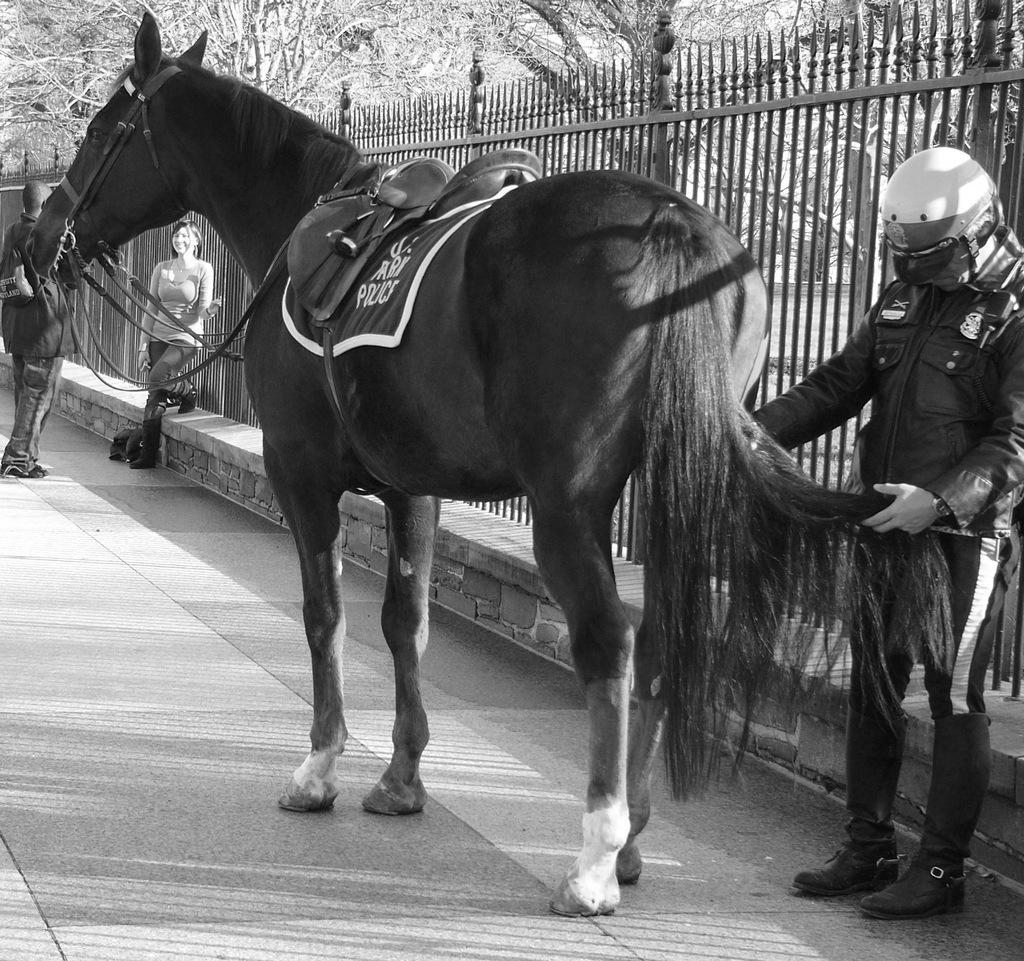How would you summarize this image in a sentence or two? In this image, we can see horse. And the right side, a human is standing. He wear a helmet on his head. And here walk way. Here woman is standing near fencing. On the left side, another human is standing. We can see trees at the background. 